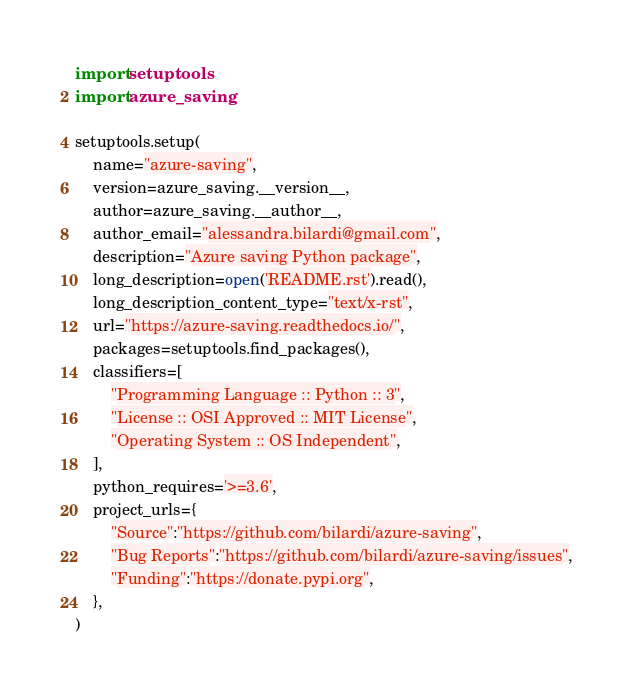Convert code to text. <code><loc_0><loc_0><loc_500><loc_500><_Python_>import setuptools
import azure_saving

setuptools.setup(
    name="azure-saving",
    version=azure_saving.__version__,
    author=azure_saving.__author__,
    author_email="alessandra.bilardi@gmail.com",
    description="Azure saving Python package",
    long_description=open('README.rst').read(),
    long_description_content_type="text/x-rst",
    url="https://azure-saving.readthedocs.io/",
    packages=setuptools.find_packages(),
    classifiers=[
        "Programming Language :: Python :: 3",
        "License :: OSI Approved :: MIT License",
        "Operating System :: OS Independent",
    ],
    python_requires='>=3.6',
    project_urls={
        "Source":"https://github.com/bilardi/azure-saving",
        "Bug Reports":"https://github.com/bilardi/azure-saving/issues",
        "Funding":"https://donate.pypi.org",
    },
)
</code> 